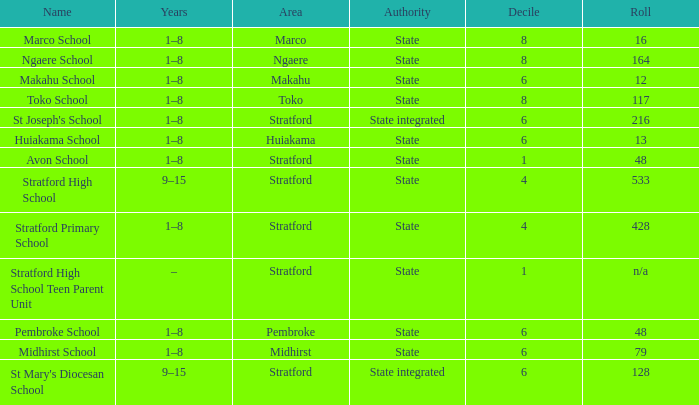What is the lowest decile with a state authority and Midhirst school? 6.0. 